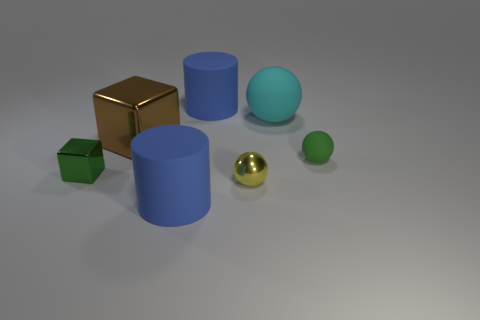How many blue cylinders must be subtracted to get 1 blue cylinders? 1 Subtract all matte spheres. How many spheres are left? 1 Subtract all green balls. How many balls are left? 2 Subtract all balls. How many objects are left? 4 Add 3 metal objects. How many objects exist? 10 Subtract 0 red blocks. How many objects are left? 7 Subtract 1 balls. How many balls are left? 2 Subtract all brown balls. Subtract all purple blocks. How many balls are left? 3 Subtract all red balls. How many yellow cubes are left? 0 Subtract all large matte objects. Subtract all large blue matte objects. How many objects are left? 2 